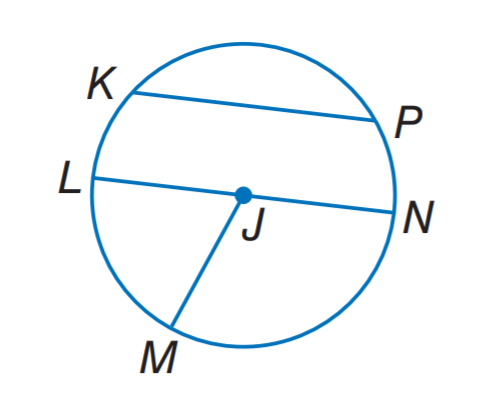Answer the mathemtical geometry problem and directly provide the correct option letter.
Question: If L N = 12.4, what is J M?
Choices: A: 3.1 B: 6.2 C: 9.3 D: 12.4 B 